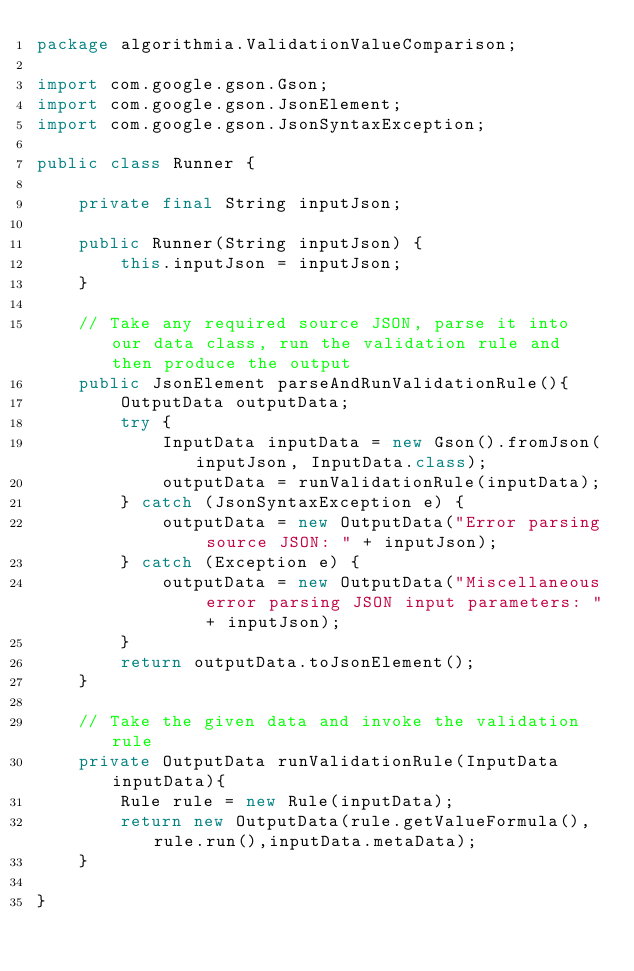Convert code to text. <code><loc_0><loc_0><loc_500><loc_500><_Java_>package algorithmia.ValidationValueComparison;

import com.google.gson.Gson;
import com.google.gson.JsonElement;
import com.google.gson.JsonSyntaxException;

public class Runner {

    private final String inputJson;

    public Runner(String inputJson) {
        this.inputJson = inputJson;
    }

    // Take any required source JSON, parse it into our data class, run the validation rule and then produce the output
    public JsonElement parseAndRunValidationRule(){
        OutputData outputData;
        try {
            InputData inputData = new Gson().fromJson(inputJson, InputData.class);
            outputData = runValidationRule(inputData);
        } catch (JsonSyntaxException e) {
            outputData = new OutputData("Error parsing source JSON: " + inputJson);
        } catch (Exception e) {
            outputData = new OutputData("Miscellaneous error parsing JSON input parameters: " + inputJson);
        }
        return outputData.toJsonElement();
    }

    // Take the given data and invoke the validation rule
    private OutputData runValidationRule(InputData inputData){
        Rule rule = new Rule(inputData);
        return new OutputData(rule.getValueFormula(),rule.run(),inputData.metaData);
    }

}
</code> 